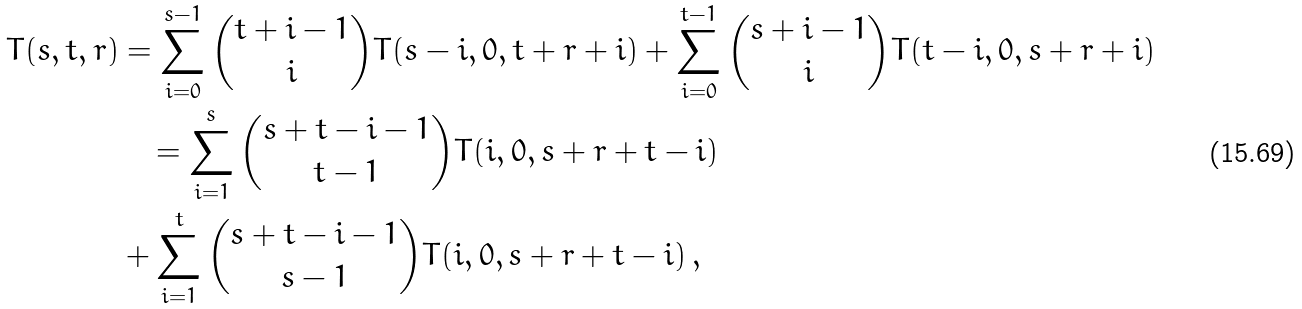<formula> <loc_0><loc_0><loc_500><loc_500>T ( s , t , r ) & = \sum _ { i = 0 } ^ { s - 1 } { \binom { t + i - 1 } i T ( s - i , 0 , t + r + i ) } + \sum _ { i = 0 } ^ { t - 1 } { \binom { s + i - 1 } i T ( t - i , 0 , s + r + i ) } \\ & \quad = \sum _ { i = 1 } ^ { s } { \binom { s + t - i - 1 } { t - 1 } T ( i , 0 , s + r + t - i ) } \\ & + \sum _ { i = 1 } ^ { t } { \binom { s + t - i - 1 } { s - 1 } T ( i , 0 , s + r + t - i ) } \, ,</formula> 